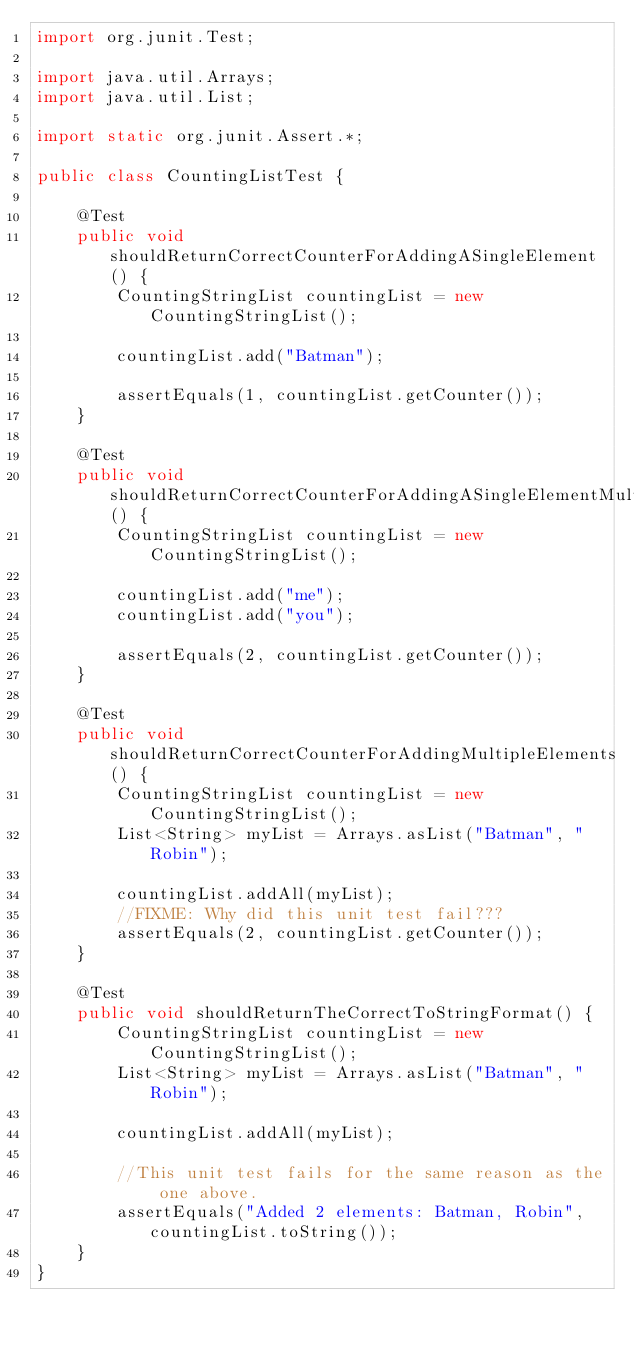Convert code to text. <code><loc_0><loc_0><loc_500><loc_500><_Java_>import org.junit.Test;

import java.util.Arrays;
import java.util.List;

import static org.junit.Assert.*;

public class CountingListTest {

    @Test
    public void shouldReturnCorrectCounterForAddingASingleElement() {
        CountingStringList countingList = new CountingStringList();

        countingList.add("Batman");

        assertEquals(1, countingList.getCounter());
    }

    @Test
    public void shouldReturnCorrectCounterForAddingASingleElementMultipleTimes() {
        CountingStringList countingList = new CountingStringList();

        countingList.add("me");
        countingList.add("you");

        assertEquals(2, countingList.getCounter());
    }

    @Test
    public void shouldReturnCorrectCounterForAddingMultipleElements() {
        CountingStringList countingList = new CountingStringList();
        List<String> myList = Arrays.asList("Batman", "Robin");

        countingList.addAll(myList);
        //FIXME: Why did this unit test fail???
        assertEquals(2, countingList.getCounter());
    }

    @Test
    public void shouldReturnTheCorrectToStringFormat() {
        CountingStringList countingList = new CountingStringList();
        List<String> myList = Arrays.asList("Batman", "Robin");

        countingList.addAll(myList);

        //This unit test fails for the same reason as the one above.
        assertEquals("Added 2 elements: Batman, Robin", countingList.toString());
    }
}
</code> 